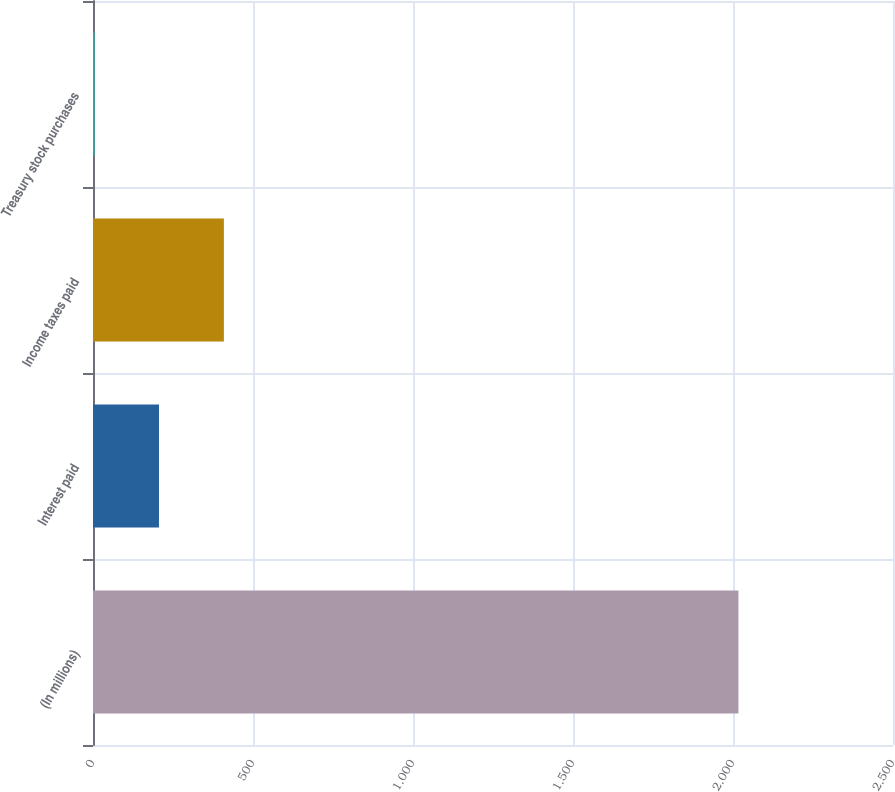<chart> <loc_0><loc_0><loc_500><loc_500><bar_chart><fcel>(In millions)<fcel>Interest paid<fcel>Income taxes paid<fcel>Treasury stock purchases<nl><fcel>2017<fcel>206.2<fcel>409<fcel>5<nl></chart> 